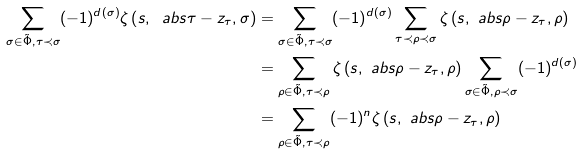Convert formula to latex. <formula><loc_0><loc_0><loc_500><loc_500>\sum _ { \sigma \in \tilde { \Phi } , \tau \prec \sigma } ( - 1 ) ^ { d ( \sigma ) } \zeta \left ( s , \ a b s { \tau } - z _ { \tau } , \sigma \right ) & = \sum _ { \sigma \in \tilde { \Phi } , \tau \prec \sigma } ( - 1 ) ^ { d ( \sigma ) } \sum _ { \tau \prec \rho \prec \sigma } \zeta \left ( s , \ a b s { \rho } - z _ { \tau } , \rho \right ) \\ & = \sum _ { \rho \in \tilde { \Phi } , \tau \prec \rho } \zeta \left ( s , \ a b s { \rho } - z _ { \tau } , \rho \right ) \sum _ { \sigma \in \tilde { \Phi } , \rho \prec \sigma } ( - 1 ) ^ { d ( \sigma ) } \\ & = \sum _ { \rho \in \tilde { \Phi } , \tau \prec \rho } ( - 1 ) ^ { n } \zeta \left ( s , \ a b s { \rho } - z _ { \tau } , \rho \right )</formula> 